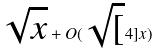Convert formula to latex. <formula><loc_0><loc_0><loc_500><loc_500>\sqrt { x } + O ( \sqrt { [ } 4 ] { x } )</formula> 